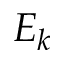Convert formula to latex. <formula><loc_0><loc_0><loc_500><loc_500>E _ { k }</formula> 